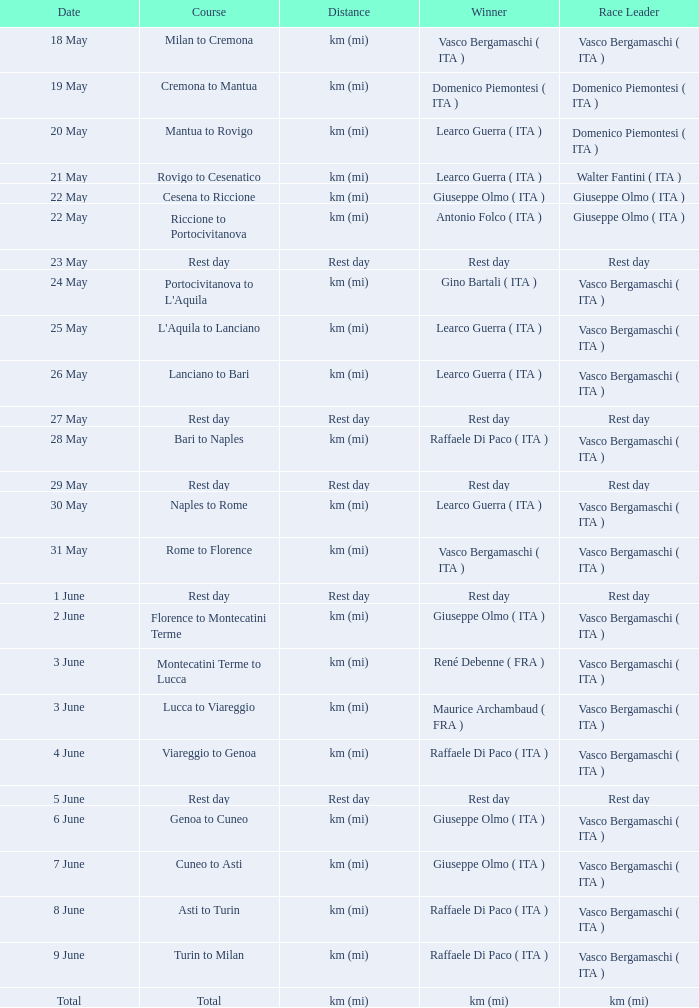Who won on 28 May? Raffaele Di Paco ( ITA ). 